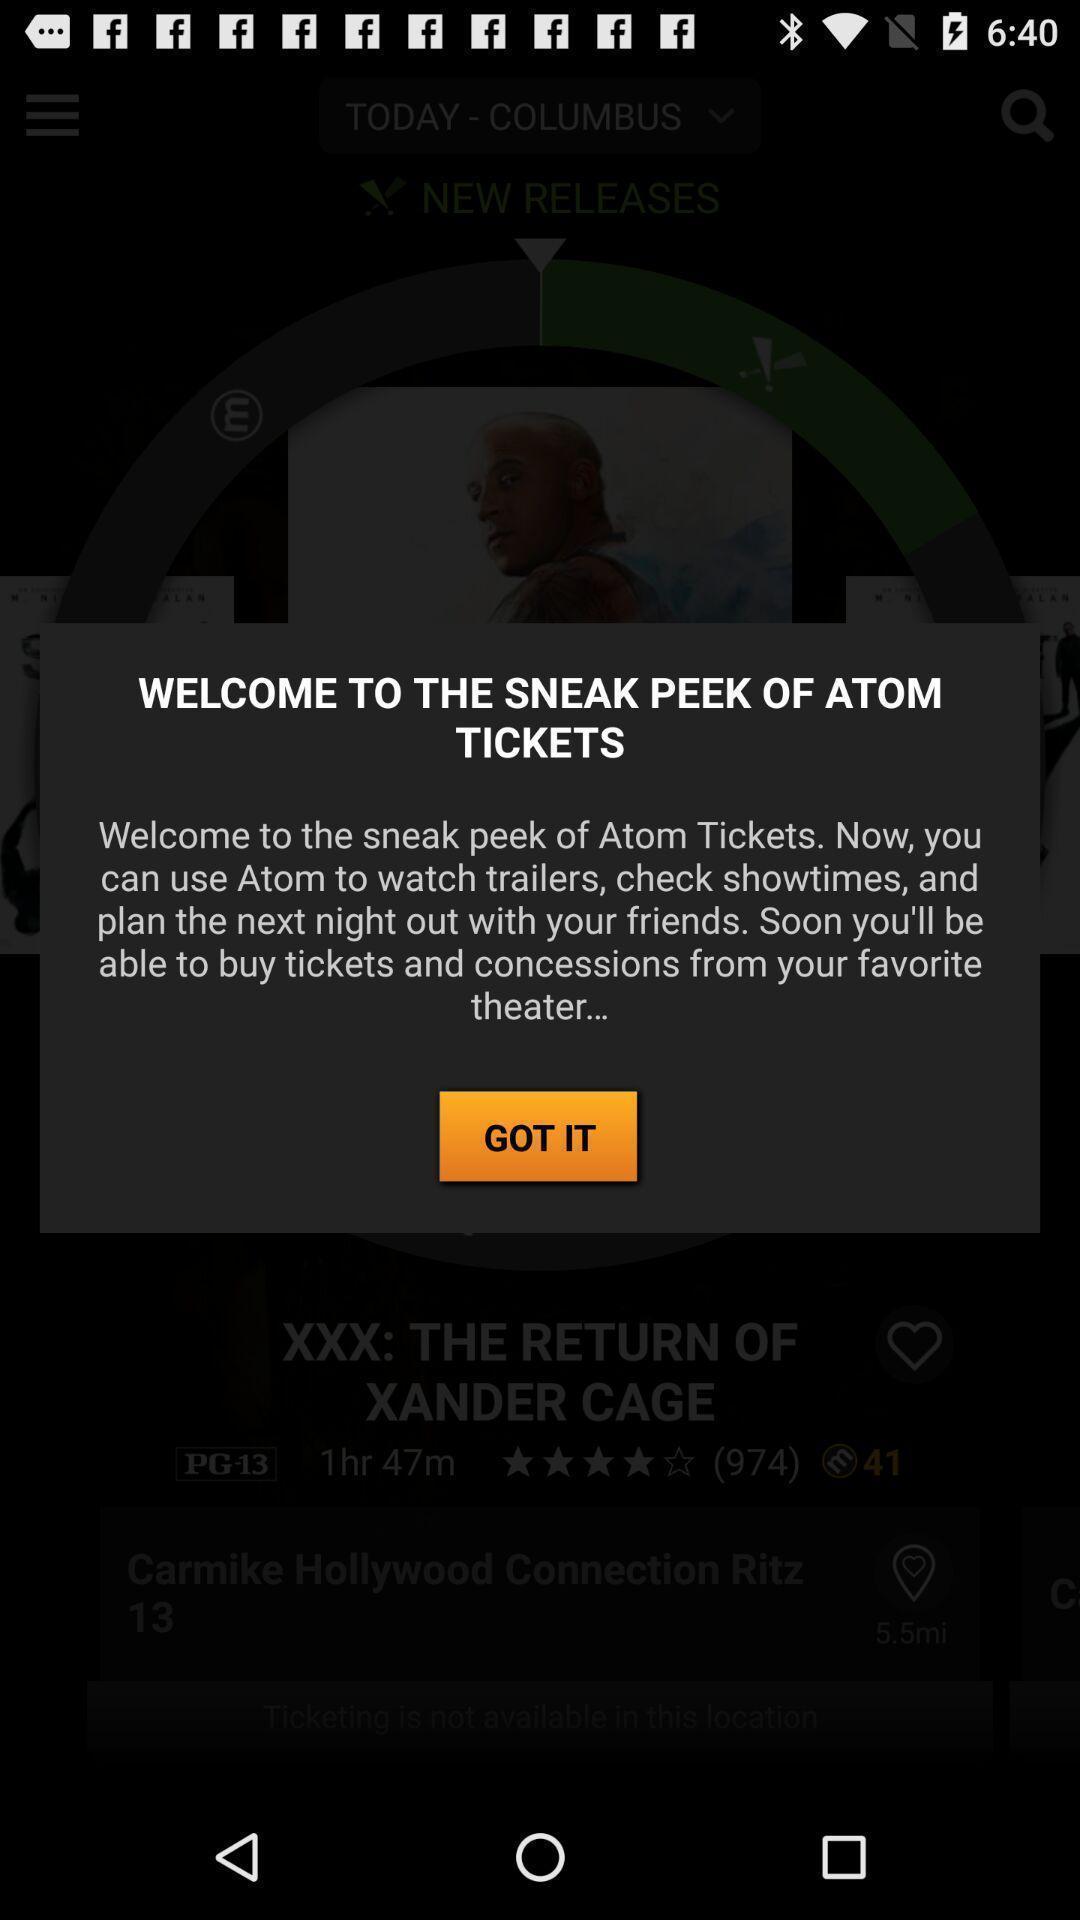What details can you identify in this image? Welcome page. 